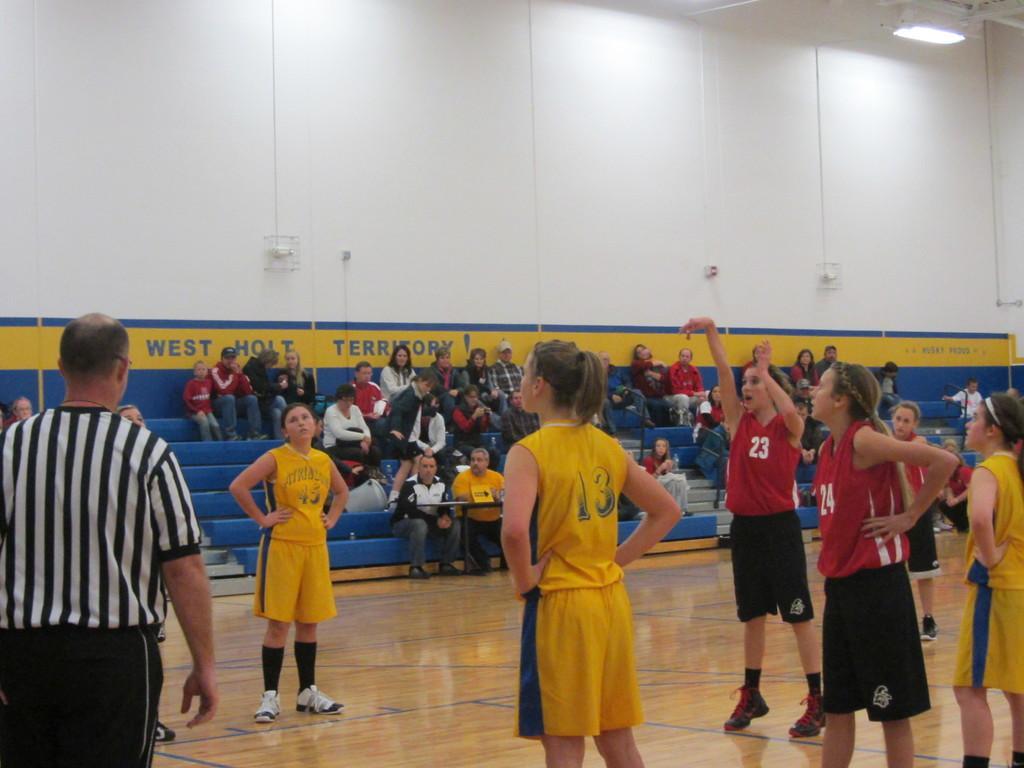Can you describe this image briefly? In this image there are a group of people some of them are wearing jersey and standing, and in the background there are some people sitting and there is a wall. On the wall there is text and at the top there are some lights, and at the bottom there is floor. 